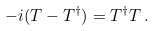<formula> <loc_0><loc_0><loc_500><loc_500>- i ( T - T ^ { \dagger } ) = T ^ { \dagger } T \, .</formula> 